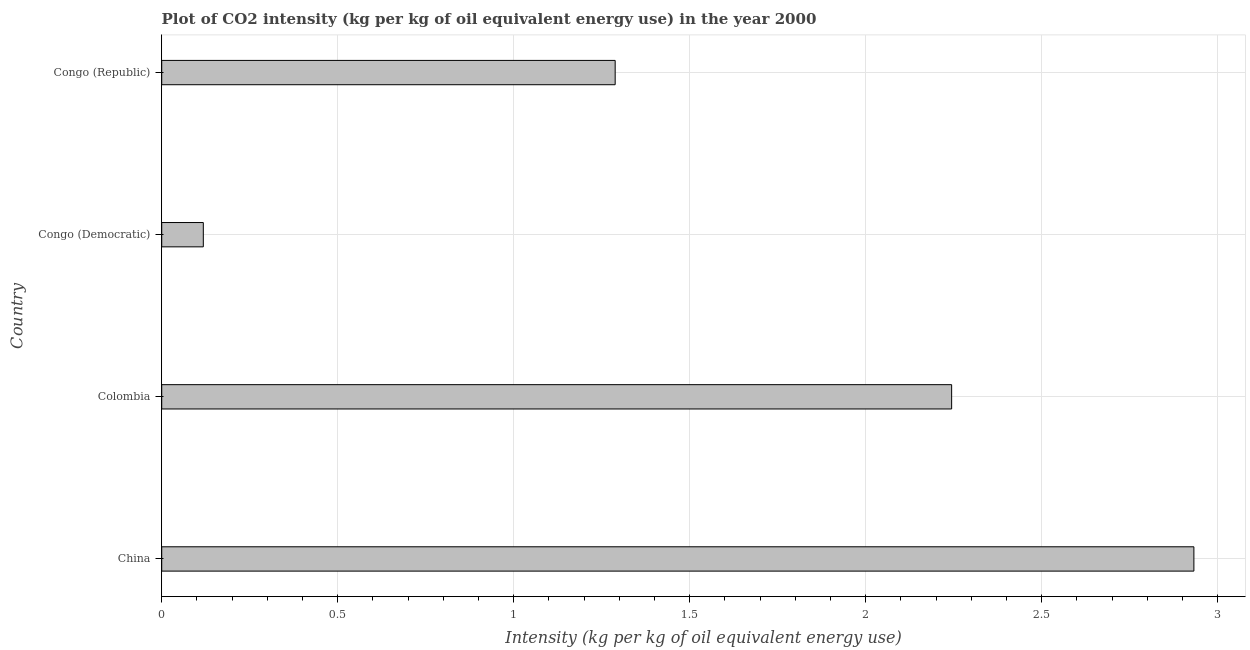Does the graph contain grids?
Keep it short and to the point. Yes. What is the title of the graph?
Your answer should be compact. Plot of CO2 intensity (kg per kg of oil equivalent energy use) in the year 2000. What is the label or title of the X-axis?
Make the answer very short. Intensity (kg per kg of oil equivalent energy use). What is the label or title of the Y-axis?
Make the answer very short. Country. What is the co2 intensity in China?
Offer a terse response. 2.93. Across all countries, what is the maximum co2 intensity?
Give a very brief answer. 2.93. Across all countries, what is the minimum co2 intensity?
Make the answer very short. 0.12. In which country was the co2 intensity maximum?
Offer a very short reply. China. In which country was the co2 intensity minimum?
Your answer should be compact. Congo (Democratic). What is the sum of the co2 intensity?
Your answer should be compact. 6.58. What is the difference between the co2 intensity in Colombia and Congo (Republic)?
Offer a very short reply. 0.96. What is the average co2 intensity per country?
Make the answer very short. 1.65. What is the median co2 intensity?
Make the answer very short. 1.77. What is the ratio of the co2 intensity in China to that in Colombia?
Make the answer very short. 1.31. Is the difference between the co2 intensity in Congo (Democratic) and Congo (Republic) greater than the difference between any two countries?
Provide a succinct answer. No. What is the difference between the highest and the second highest co2 intensity?
Give a very brief answer. 0.69. What is the difference between the highest and the lowest co2 intensity?
Your response must be concise. 2.81. In how many countries, is the co2 intensity greater than the average co2 intensity taken over all countries?
Make the answer very short. 2. Are all the bars in the graph horizontal?
Keep it short and to the point. Yes. How many countries are there in the graph?
Your answer should be compact. 4. Are the values on the major ticks of X-axis written in scientific E-notation?
Offer a very short reply. No. What is the Intensity (kg per kg of oil equivalent energy use) in China?
Your response must be concise. 2.93. What is the Intensity (kg per kg of oil equivalent energy use) of Colombia?
Your response must be concise. 2.24. What is the Intensity (kg per kg of oil equivalent energy use) of Congo (Democratic)?
Keep it short and to the point. 0.12. What is the Intensity (kg per kg of oil equivalent energy use) of Congo (Republic)?
Keep it short and to the point. 1.29. What is the difference between the Intensity (kg per kg of oil equivalent energy use) in China and Colombia?
Offer a terse response. 0.69. What is the difference between the Intensity (kg per kg of oil equivalent energy use) in China and Congo (Democratic)?
Your response must be concise. 2.81. What is the difference between the Intensity (kg per kg of oil equivalent energy use) in China and Congo (Republic)?
Your answer should be very brief. 1.64. What is the difference between the Intensity (kg per kg of oil equivalent energy use) in Colombia and Congo (Democratic)?
Provide a succinct answer. 2.13. What is the difference between the Intensity (kg per kg of oil equivalent energy use) in Colombia and Congo (Republic)?
Provide a succinct answer. 0.96. What is the difference between the Intensity (kg per kg of oil equivalent energy use) in Congo (Democratic) and Congo (Republic)?
Your answer should be compact. -1.17. What is the ratio of the Intensity (kg per kg of oil equivalent energy use) in China to that in Colombia?
Provide a succinct answer. 1.31. What is the ratio of the Intensity (kg per kg of oil equivalent energy use) in China to that in Congo (Democratic)?
Your answer should be compact. 24.81. What is the ratio of the Intensity (kg per kg of oil equivalent energy use) in China to that in Congo (Republic)?
Keep it short and to the point. 2.28. What is the ratio of the Intensity (kg per kg of oil equivalent energy use) in Colombia to that in Congo (Democratic)?
Keep it short and to the point. 18.99. What is the ratio of the Intensity (kg per kg of oil equivalent energy use) in Colombia to that in Congo (Republic)?
Keep it short and to the point. 1.74. What is the ratio of the Intensity (kg per kg of oil equivalent energy use) in Congo (Democratic) to that in Congo (Republic)?
Your response must be concise. 0.09. 